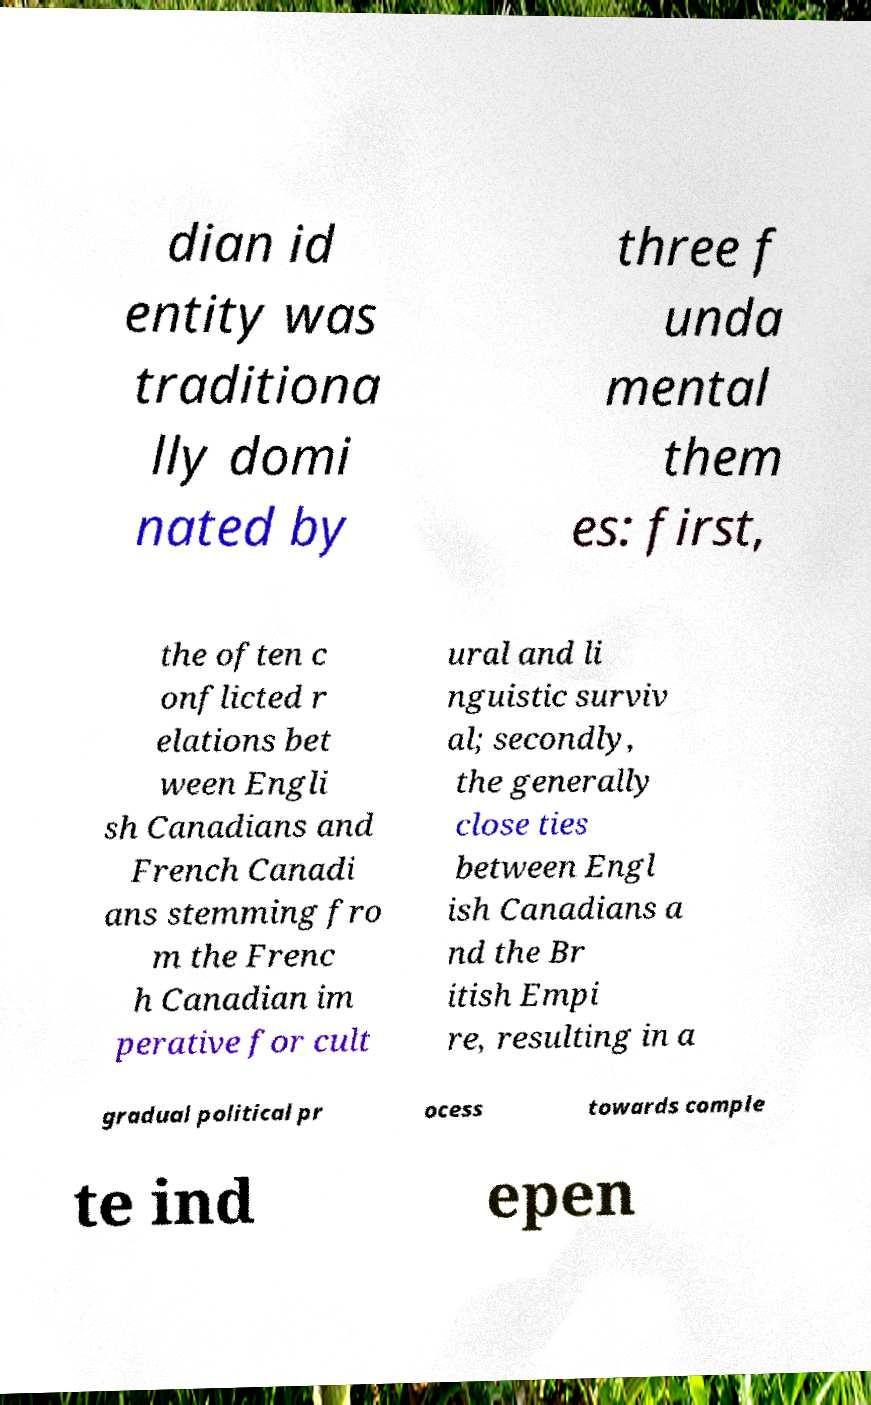Please identify and transcribe the text found in this image. dian id entity was traditiona lly domi nated by three f unda mental them es: first, the often c onflicted r elations bet ween Engli sh Canadians and French Canadi ans stemming fro m the Frenc h Canadian im perative for cult ural and li nguistic surviv al; secondly, the generally close ties between Engl ish Canadians a nd the Br itish Empi re, resulting in a gradual political pr ocess towards comple te ind epen 